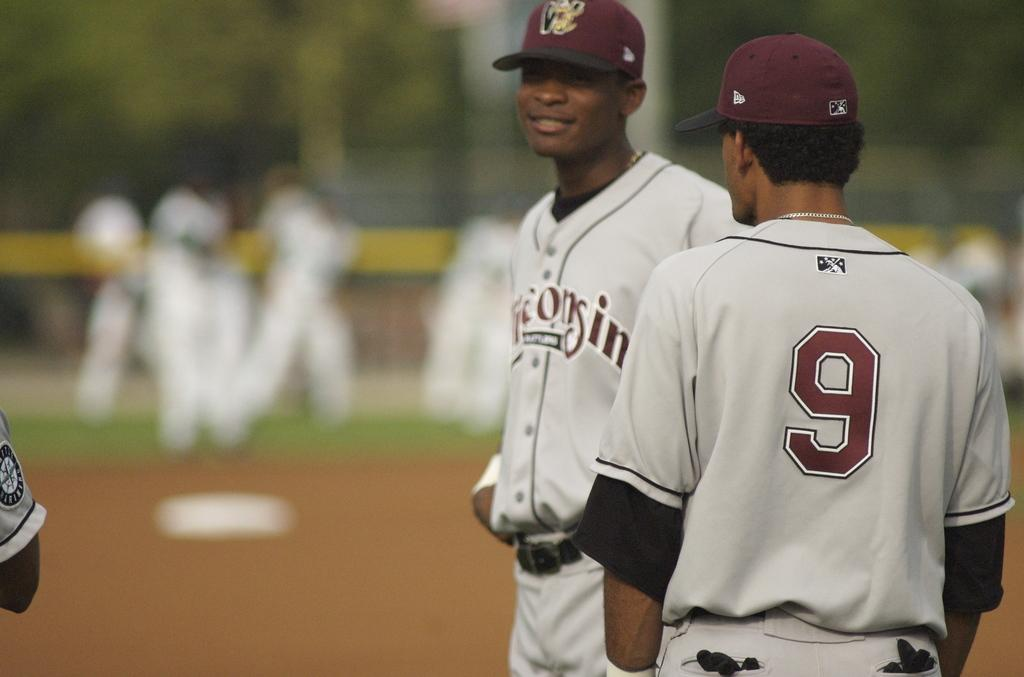<image>
Write a terse but informative summary of the picture. The player next to player number number 9 is smiling. 